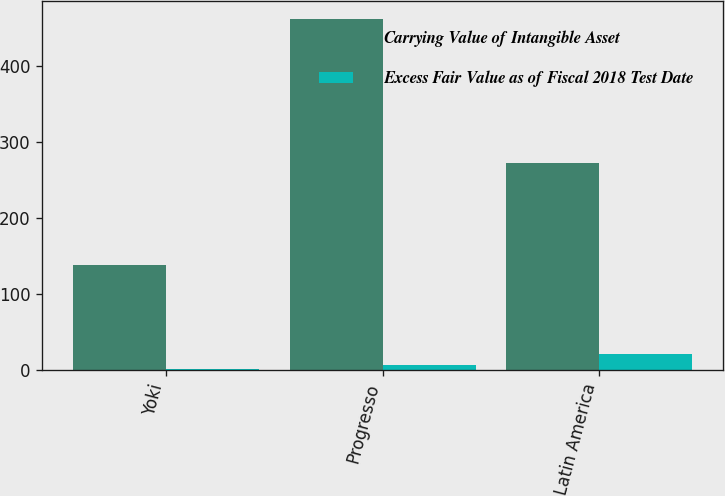Convert chart to OTSL. <chart><loc_0><loc_0><loc_500><loc_500><stacked_bar_chart><ecel><fcel>Yoki<fcel>Progresso<fcel>Latin America<nl><fcel>Carrying Value of Intangible Asset<fcel>138.2<fcel>462.1<fcel>272<nl><fcel>Excess Fair Value as of Fiscal 2018 Test Date<fcel>1<fcel>6<fcel>21<nl></chart> 